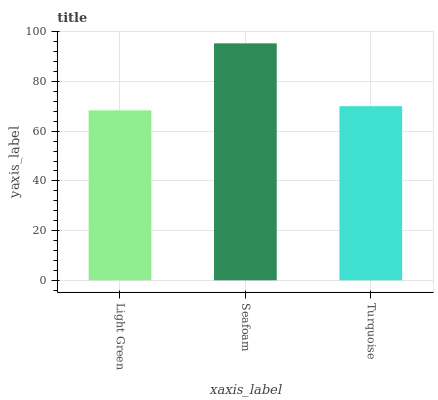Is Light Green the minimum?
Answer yes or no. Yes. Is Seafoam the maximum?
Answer yes or no. Yes. Is Turquoise the minimum?
Answer yes or no. No. Is Turquoise the maximum?
Answer yes or no. No. Is Seafoam greater than Turquoise?
Answer yes or no. Yes. Is Turquoise less than Seafoam?
Answer yes or no. Yes. Is Turquoise greater than Seafoam?
Answer yes or no. No. Is Seafoam less than Turquoise?
Answer yes or no. No. Is Turquoise the high median?
Answer yes or no. Yes. Is Turquoise the low median?
Answer yes or no. Yes. Is Light Green the high median?
Answer yes or no. No. Is Light Green the low median?
Answer yes or no. No. 